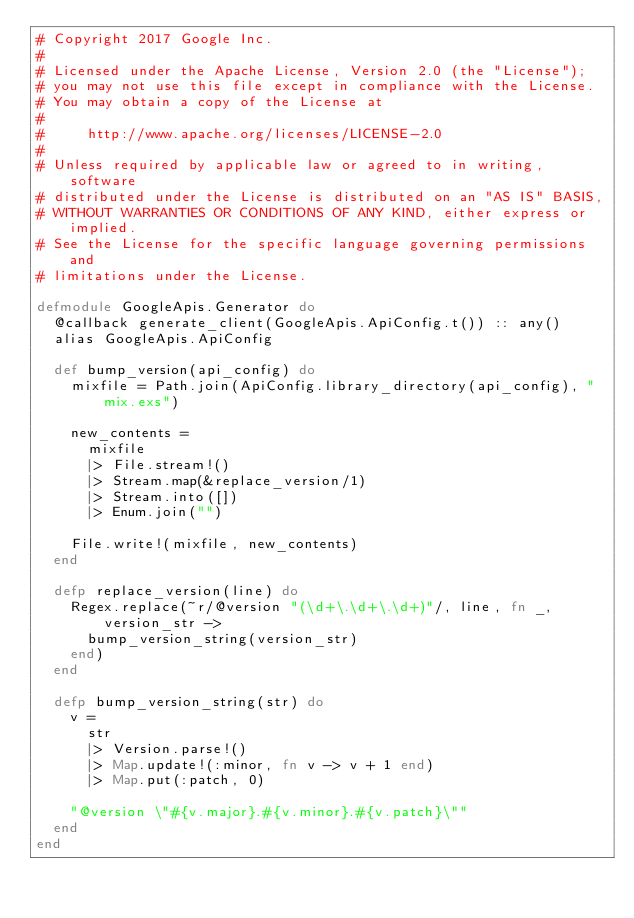<code> <loc_0><loc_0><loc_500><loc_500><_Elixir_># Copyright 2017 Google Inc.
#
# Licensed under the Apache License, Version 2.0 (the "License");
# you may not use this file except in compliance with the License.
# You may obtain a copy of the License at
#
#     http://www.apache.org/licenses/LICENSE-2.0
#
# Unless required by applicable law or agreed to in writing, software
# distributed under the License is distributed on an "AS IS" BASIS,
# WITHOUT WARRANTIES OR CONDITIONS OF ANY KIND, either express or implied.
# See the License for the specific language governing permissions and
# limitations under the License.

defmodule GoogleApis.Generator do
  @callback generate_client(GoogleApis.ApiConfig.t()) :: any()
  alias GoogleApis.ApiConfig

  def bump_version(api_config) do
    mixfile = Path.join(ApiConfig.library_directory(api_config), "mix.exs")

    new_contents =
      mixfile
      |> File.stream!()
      |> Stream.map(&replace_version/1)
      |> Stream.into([])
      |> Enum.join("")

    File.write!(mixfile, new_contents)
  end

  defp replace_version(line) do
    Regex.replace(~r/@version "(\d+\.\d+\.\d+)"/, line, fn _, version_str ->
      bump_version_string(version_str)
    end)
  end

  defp bump_version_string(str) do
    v =
      str
      |> Version.parse!()
      |> Map.update!(:minor, fn v -> v + 1 end)
      |> Map.put(:patch, 0)

    "@version \"#{v.major}.#{v.minor}.#{v.patch}\""
  end
end
</code> 